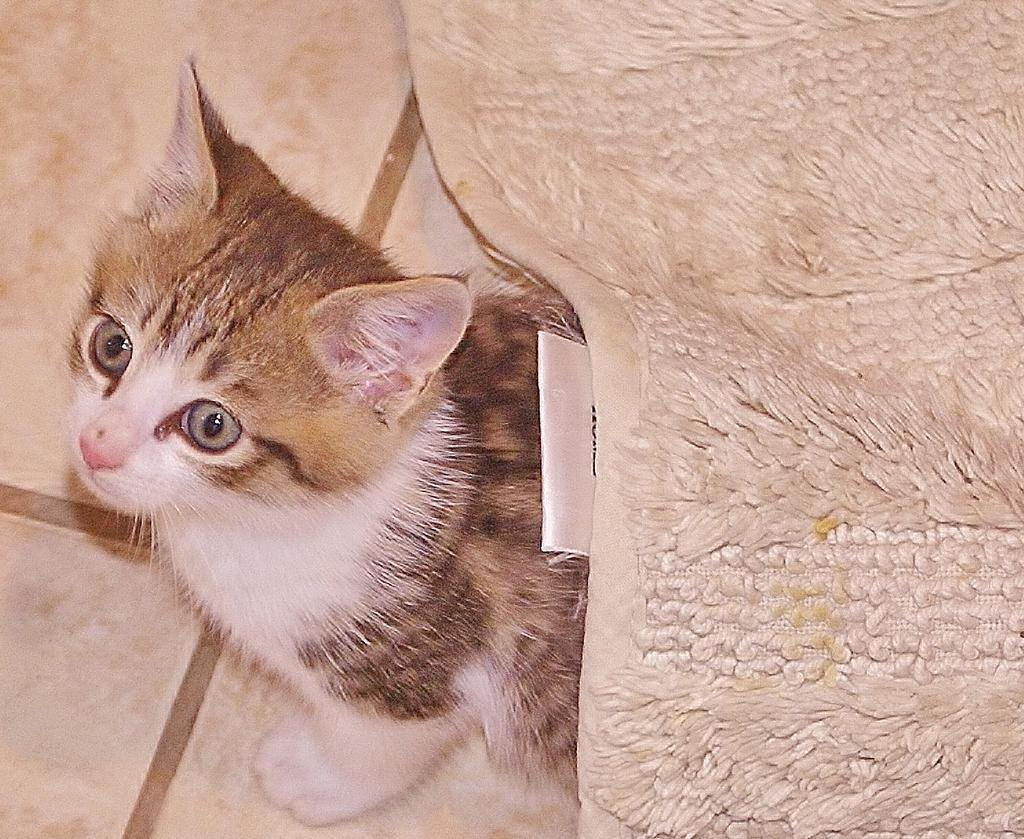What type of animal is present in the image? There is a cat in the image. Where is the cat located? The cat is on the floor. What is covering the floor in the image? The floor is covered by a blanket. What type of vehicle is the cat driving in the image? There is no vehicle present in the image, and the cat is not driving anything. 